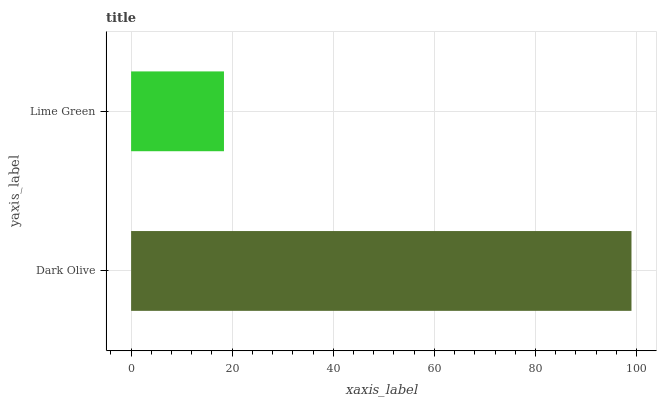Is Lime Green the minimum?
Answer yes or no. Yes. Is Dark Olive the maximum?
Answer yes or no. Yes. Is Lime Green the maximum?
Answer yes or no. No. Is Dark Olive greater than Lime Green?
Answer yes or no. Yes. Is Lime Green less than Dark Olive?
Answer yes or no. Yes. Is Lime Green greater than Dark Olive?
Answer yes or no. No. Is Dark Olive less than Lime Green?
Answer yes or no. No. Is Dark Olive the high median?
Answer yes or no. Yes. Is Lime Green the low median?
Answer yes or no. Yes. Is Lime Green the high median?
Answer yes or no. No. Is Dark Olive the low median?
Answer yes or no. No. 